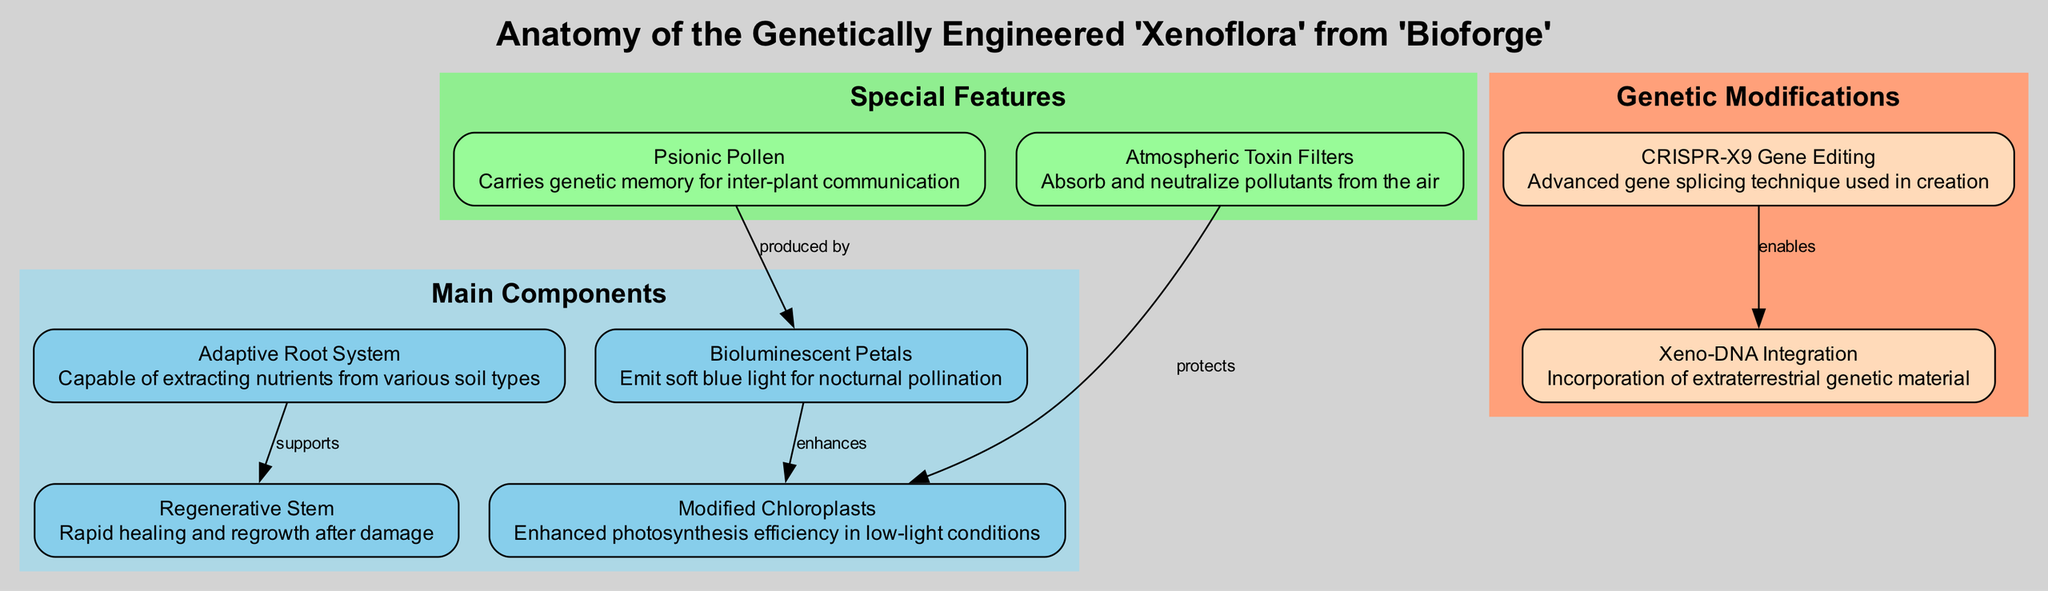What is the primary function of the Bioluminescent Petals? The Bioluminescent Petals emit soft blue light which attracts nocturnal pollinators. This information can be found within the description associated with the Bioluminescent Petals in the diagram.
Answer: Emit soft blue light for nocturnal pollination How many main components are shown in the diagram? By counting the nodes categorized under "Main Components," I see there are four nodes listed: Bioluminescent Petals, Adaptive Root System, Modified Chloroplasts, and Regenerative Stem. Therefore, the total count of main components is four.
Answer: 4 What supports the Regenerative Stem? The diagram indicates that the Adaptive Root System supports the Regenerative Stem, as evidenced by the edge labeled "supports" connecting these two nodes.
Answer: Adaptive Root System Which genetic modification enables the incorporation of extraterrestrial DNA? The diagram connects CRISPR-X9 Gene Editing to Xeno-DNA Integration with an edge labeled "enables," indicating that it is CRISPR-X9 Gene Editing that allows the incorporation of Xeno-DNA.
Answer: CRISPR-X9 Gene Editing How does the Atmospheric Toxin Filters affect the Modified Chloroplasts? The relationship indicated by the edge labeled "protects" suggests that the Atmospheric Toxin Filters play a protective role for the Modified Chloroplasts by absorbing and neutralizing airborne pollutants, enhancing their function.
Answer: Protects What connects the Psionic Pollen and the Bioluminescent Petals? The diagram shows an edge marked "produced by" that connects Psionic Pollen to Bioluminescent Petals, indicating that the Bioluminescent Petals are produced by Psionic Pollen.
Answer: Produced by Which special feature neutralizes pollutants from the air? The specific feature identified in the diagram is the Atmospheric Toxin Filters, which is described as being responsible for absorbing and neutralizing airborne pollutants. This conclusion is directly drawn from the label associated with that node.
Answer: Atmospheric Toxin Filters What is the collective purpose of the Modified Chloroplasts? The diagram highlights that the Modified Chloroplasts are designed for enhanced photosynthesis efficiency, particularly in low-light conditions, which speaks to their role in plant survival.
Answer: Enhanced photosynthesis efficiency in low-light conditions What is the unique feature of the Psionic Pollen regarding plant communication? Psionic Pollen is noted in the diagram for carrying genetic memory, which facilitates inter-plant communication, thus providing a unique form of interaction between plants.
Answer: Carries genetic memory for inter-plant communication 